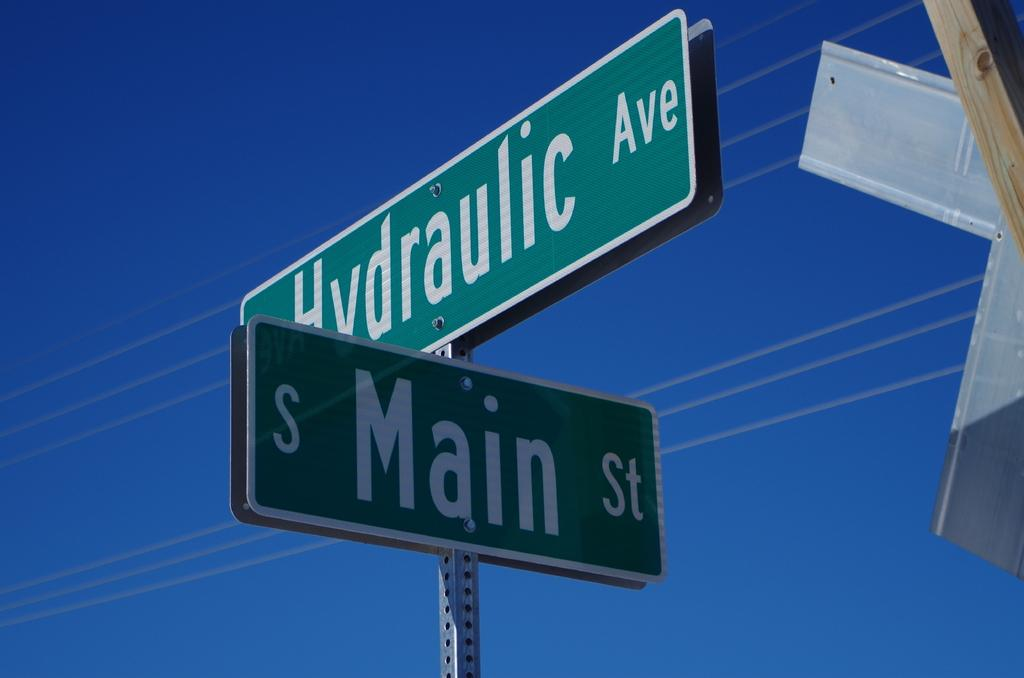Provide a one-sentence caption for the provided image. Blue sky on the corner of Main St. and Hydraulic Ave. 